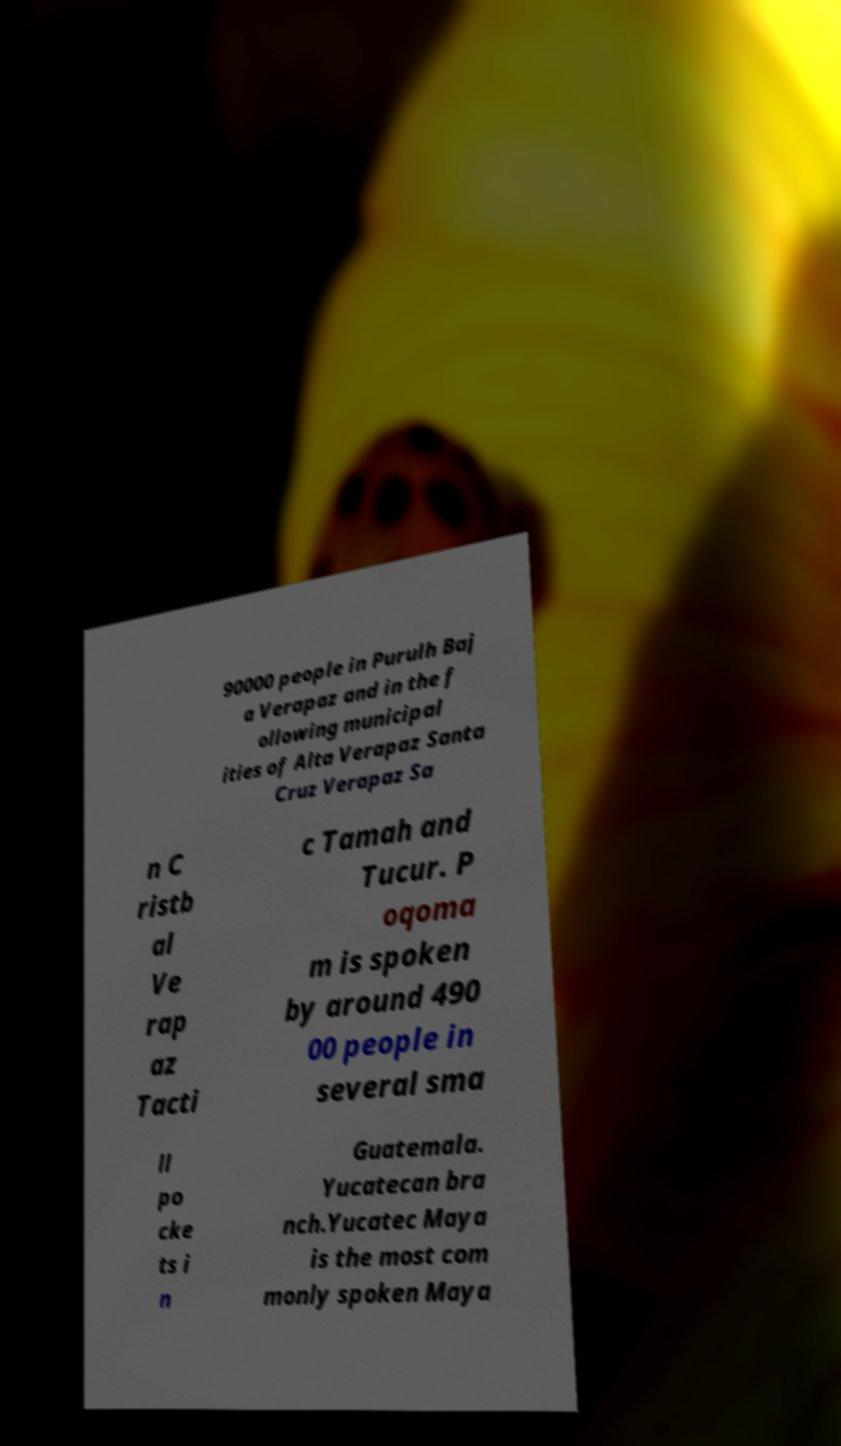Can you accurately transcribe the text from the provided image for me? 90000 people in Purulh Baj a Verapaz and in the f ollowing municipal ities of Alta Verapaz Santa Cruz Verapaz Sa n C ristb al Ve rap az Tacti c Tamah and Tucur. P oqoma m is spoken by around 490 00 people in several sma ll po cke ts i n Guatemala. Yucatecan bra nch.Yucatec Maya is the most com monly spoken Maya 